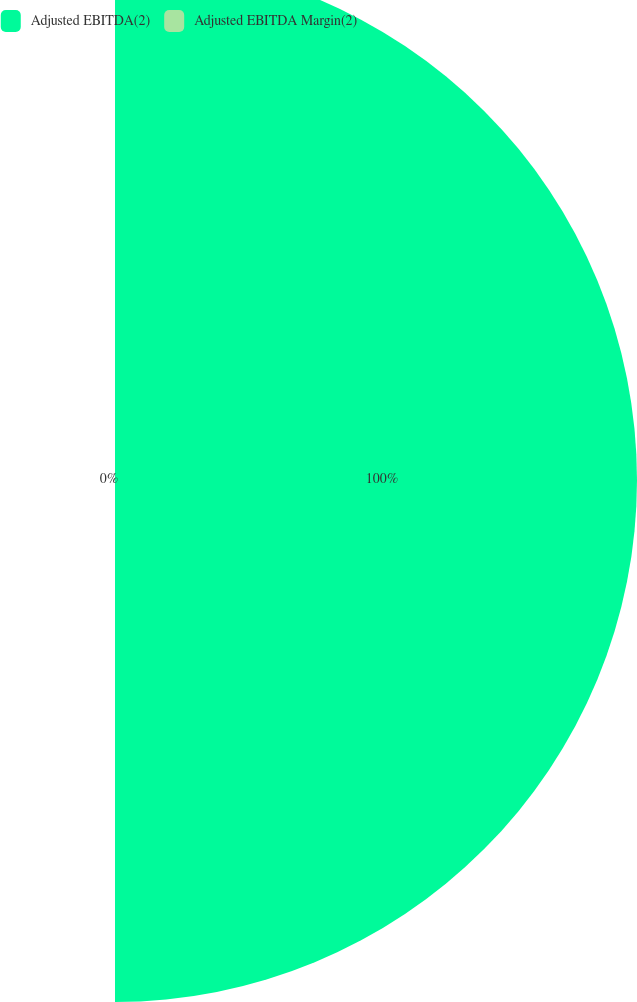Convert chart to OTSL. <chart><loc_0><loc_0><loc_500><loc_500><pie_chart><fcel>Adjusted EBITDA(2)<fcel>Adjusted EBITDA Margin(2)<nl><fcel>100.0%<fcel>0.0%<nl></chart> 